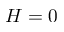Convert formula to latex. <formula><loc_0><loc_0><loc_500><loc_500>H = 0</formula> 